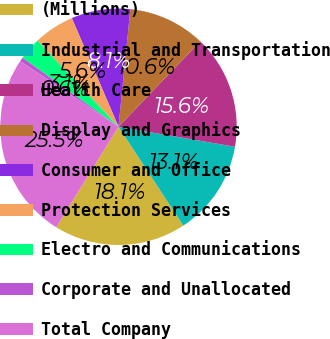Convert chart to OTSL. <chart><loc_0><loc_0><loc_500><loc_500><pie_chart><fcel>(Millions)<fcel>Industrial and Transportation<fcel>Health Care<fcel>Display and Graphics<fcel>Consumer and Office<fcel>Protection Services<fcel>Electro and Communications<fcel>Corporate and Unallocated<fcel>Total Company<nl><fcel>18.06%<fcel>13.06%<fcel>15.56%<fcel>10.56%<fcel>8.06%<fcel>5.56%<fcel>3.06%<fcel>0.56%<fcel>25.55%<nl></chart> 